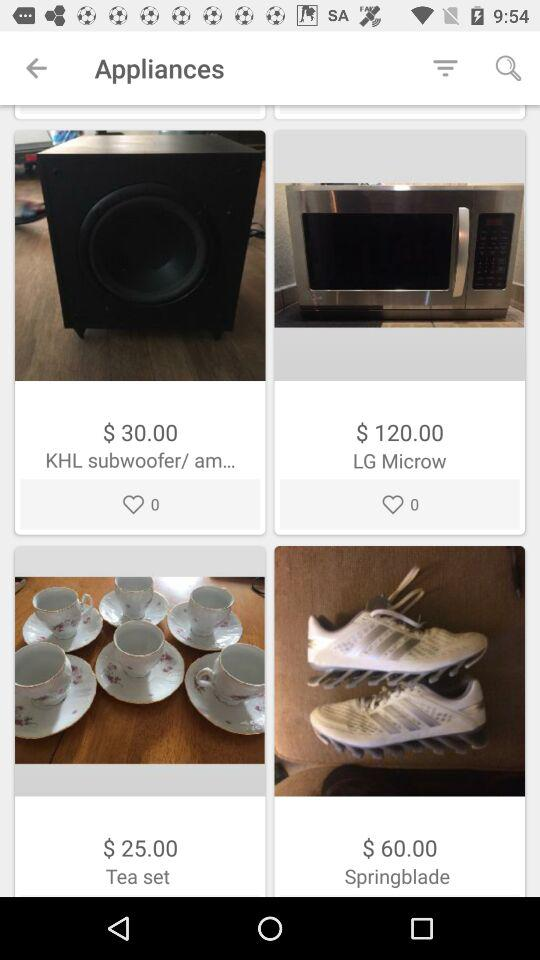How many likes does the tea set have?
When the provided information is insufficient, respond with <no answer>. <no answer> 